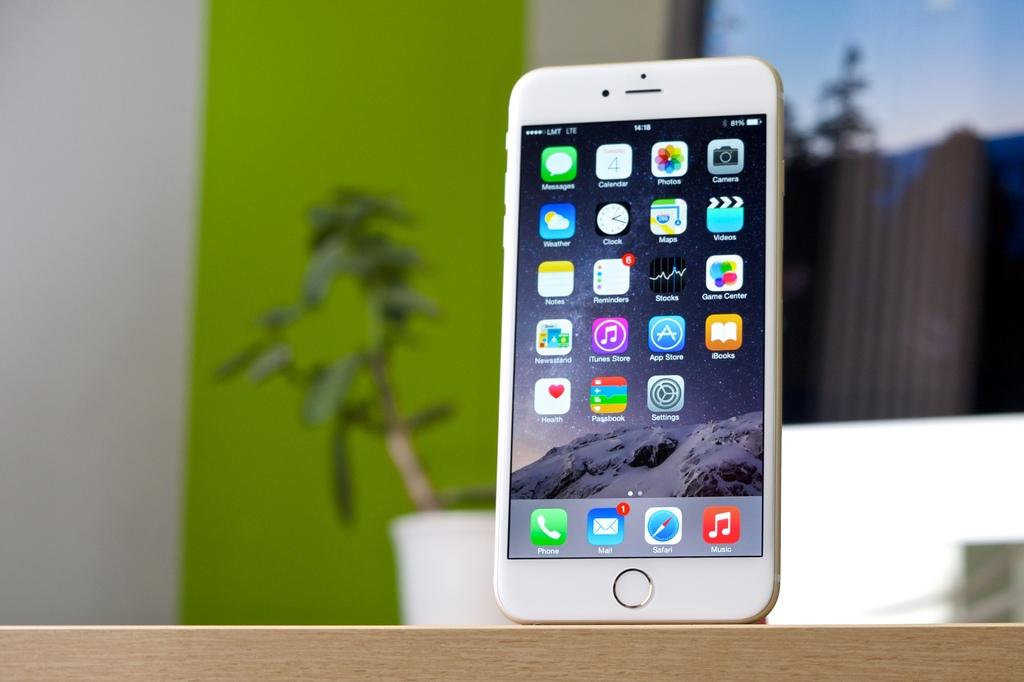How many emails does the phone have?
Provide a succinct answer. 1. What is the name of one of the apps displayed?
Provide a succinct answer. Mail. 